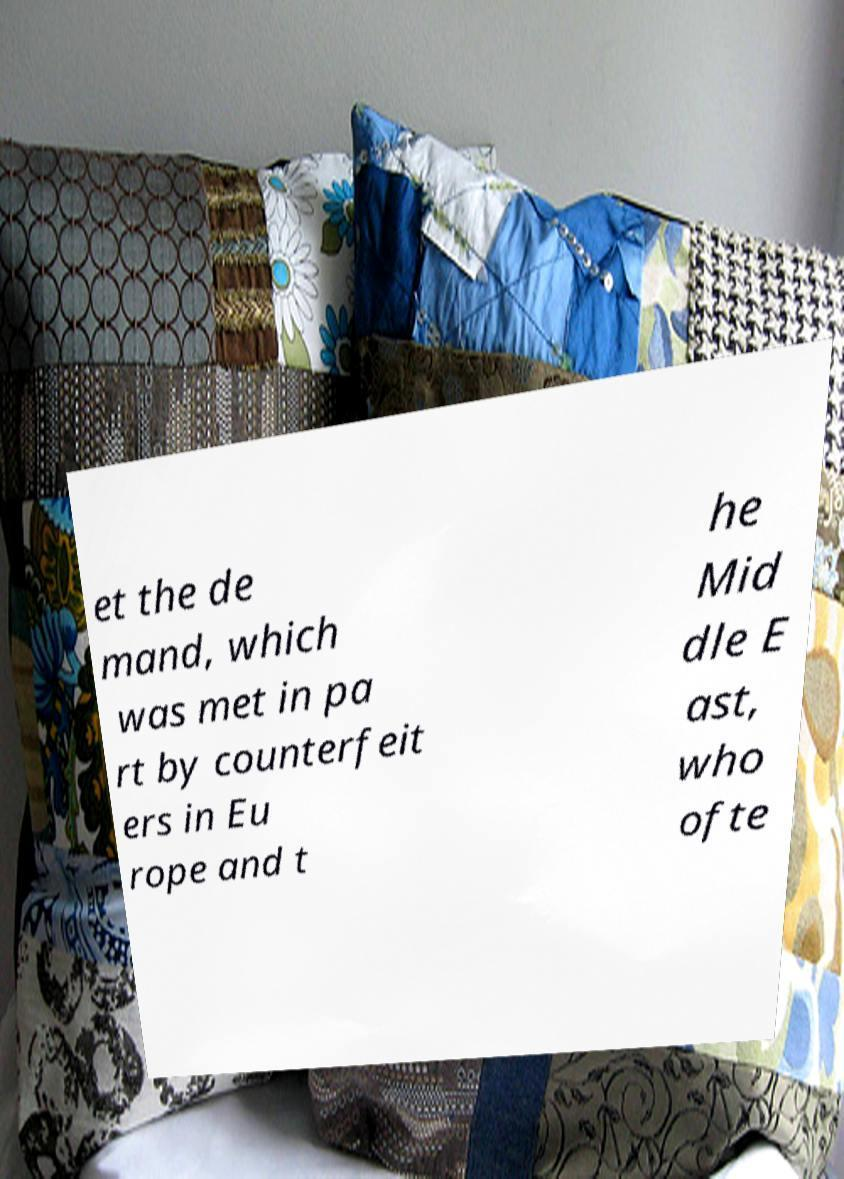For documentation purposes, I need the text within this image transcribed. Could you provide that? et the de mand, which was met in pa rt by counterfeit ers in Eu rope and t he Mid dle E ast, who ofte 